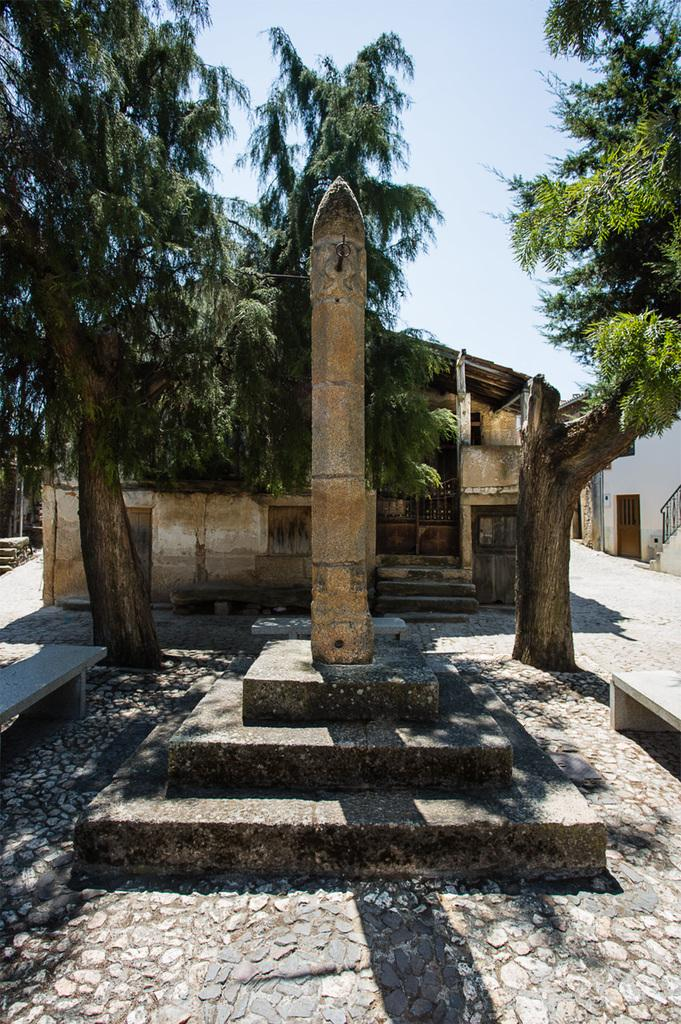What type of vegetation can be seen in the image? There are trees in the image. What structures are present in the image? There are sheds in the image. What object is located in the center of the image? There is a stone in the center of the image. What type of seating is available in the image? There are benches in the image. What is visible in the background of the image? The sky is visible in the image. What type of crime is being committed in the image? There is no indication of any crime being committed in the image. What is the source of shame in the image? There is no shame present in the image. 